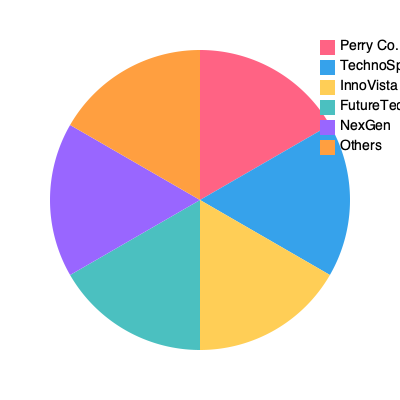Based on the pie chart showing market share of different companies in the tech industry, which two companies combined have a market share equal to that of Perry Co.? To solve this question, we need to follow these steps:

1. Observe that Perry Co. has the largest market share, represented by the red slice.
2. Visually estimate that Perry Co.'s share is about 30% of the total market.
3. Look for two companies whose combined market share appears to be equal to Perry Co.'s share.
4. Notice that TechnoSphere (blue) and InnoVista (yellow) have slices that, when combined, appear to be equal to Perry Co.'s slice.
5. Verify that no other combination of two companies seems to match Perry Co.'s market share as closely.

The visual estimation is key here, as exact percentages are not provided. The blue and yellow slices together form a semicircle, which is equivalent to the red slice representing Perry Co.'s market share.
Answer: TechnoSphere and InnoVista 